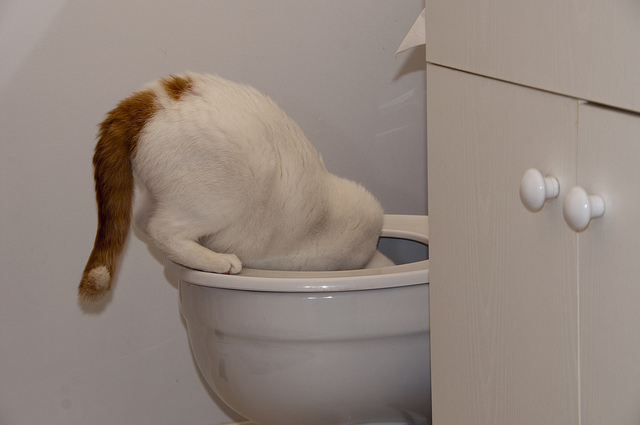<image>What pattern is on the bowl? There is no pattern on the bowl. It is plain and solid white. What pattern is on the bowl? I am not sure what pattern is on the bowl. It can be seen 'no pattern', 'none', 'white', 'solid', 'solid white', or 'plain'. 